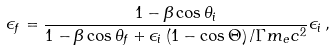<formula> <loc_0><loc_0><loc_500><loc_500>\epsilon _ { f } = \frac { 1 - \beta \cos \theta _ { i } } { 1 - \beta \cos \theta _ { f } + \epsilon _ { i } \left ( 1 - \cos \Theta \right ) / \Gamma m _ { e } c ^ { 2 } } \epsilon _ { i } \, ,</formula> 